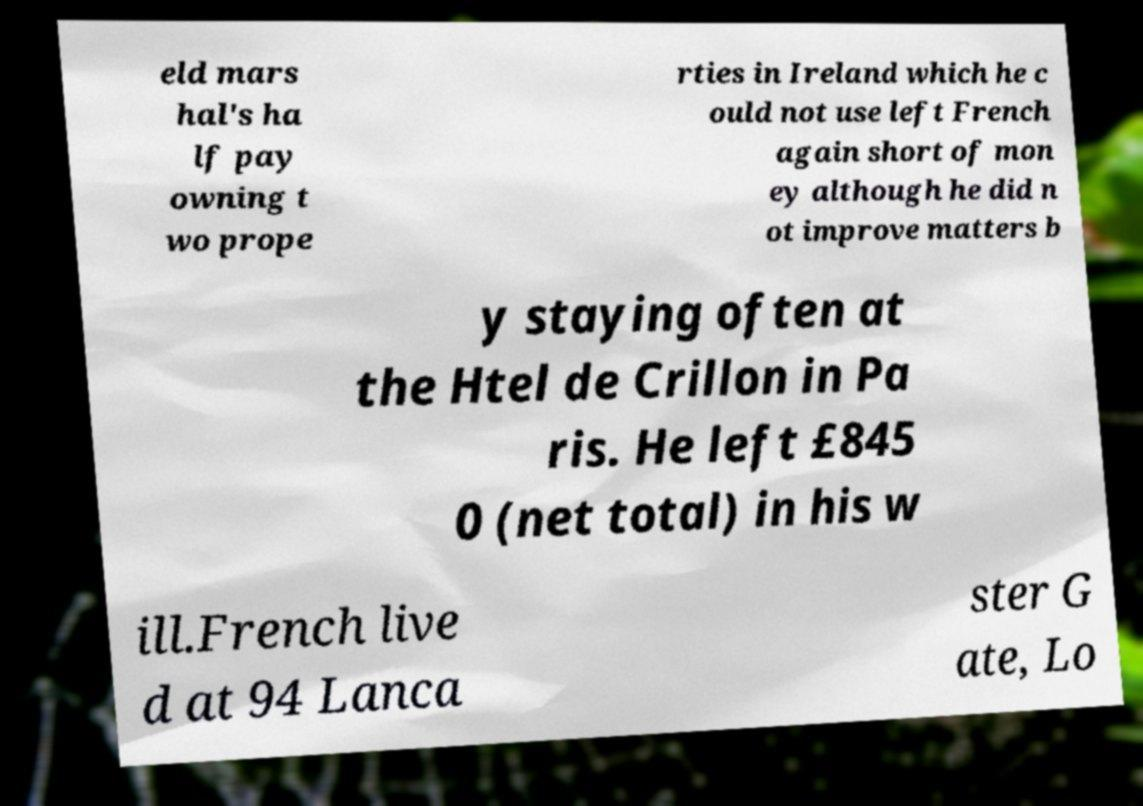For documentation purposes, I need the text within this image transcribed. Could you provide that? eld mars hal's ha lf pay owning t wo prope rties in Ireland which he c ould not use left French again short of mon ey although he did n ot improve matters b y staying often at the Htel de Crillon in Pa ris. He left £845 0 (net total) in his w ill.French live d at 94 Lanca ster G ate, Lo 